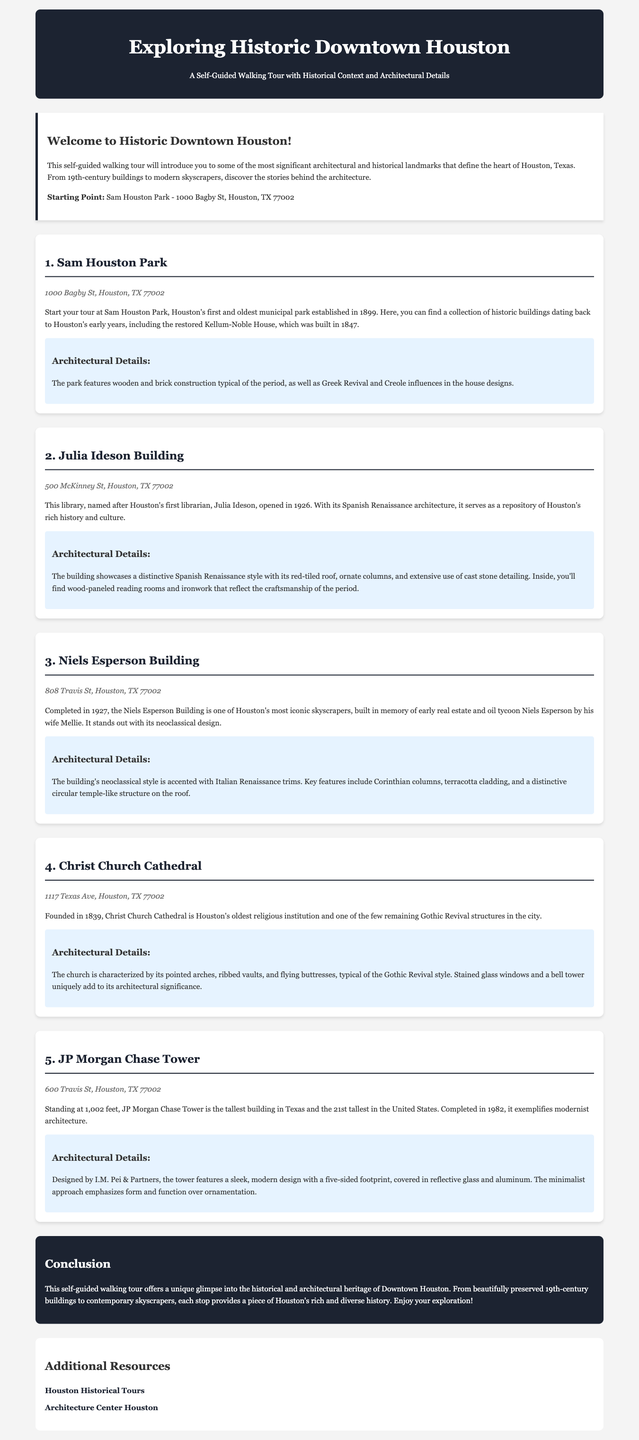what is the starting point of the tour? The starting point is clearly mentioned in the introduction section of the document.
Answer: Sam Houston Park when was Sam Houston Park established? The establishment date is provided in the description of Sam Houston Park.
Answer: 1899 who is the Julia Ideson Building named after? The document states that the building is named after Houston's first librarian.
Answer: Julia Ideson how tall is the JP Morgan Chase Tower? The height of the building is specified in the description of JP Morgan Chase Tower.
Answer: 1,002 feet which architectural style is Christ Church Cathedral characterized by? The architectural style of Christ Church Cathedral is mentioned in its respective section.
Answer: Gothic Revival what year was the Niels Esperson Building completed? The completion year is provided in the description of the Niels Esperson Building.
Answer: 1927 what is noteworthy about the architectural details of the JP Morgan Chase Tower? The document highlights key features of its architectural design.
Answer: Modern architecture how is the Julia Ideson Building's architectural style described? The architectural style is specified in the architectural details of the building description.
Answer: Spanish Renaissance which park is the first stop on the walking tour? The first stop is clearly named in the document's sequence of stops.
Answer: Sam Houston Park 